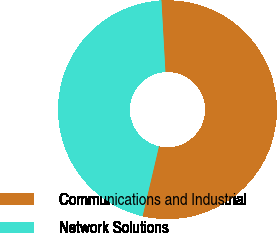<chart> <loc_0><loc_0><loc_500><loc_500><pie_chart><fcel>Communications and Industrial<fcel>Network Solutions<nl><fcel>54.55%<fcel>45.45%<nl></chart> 